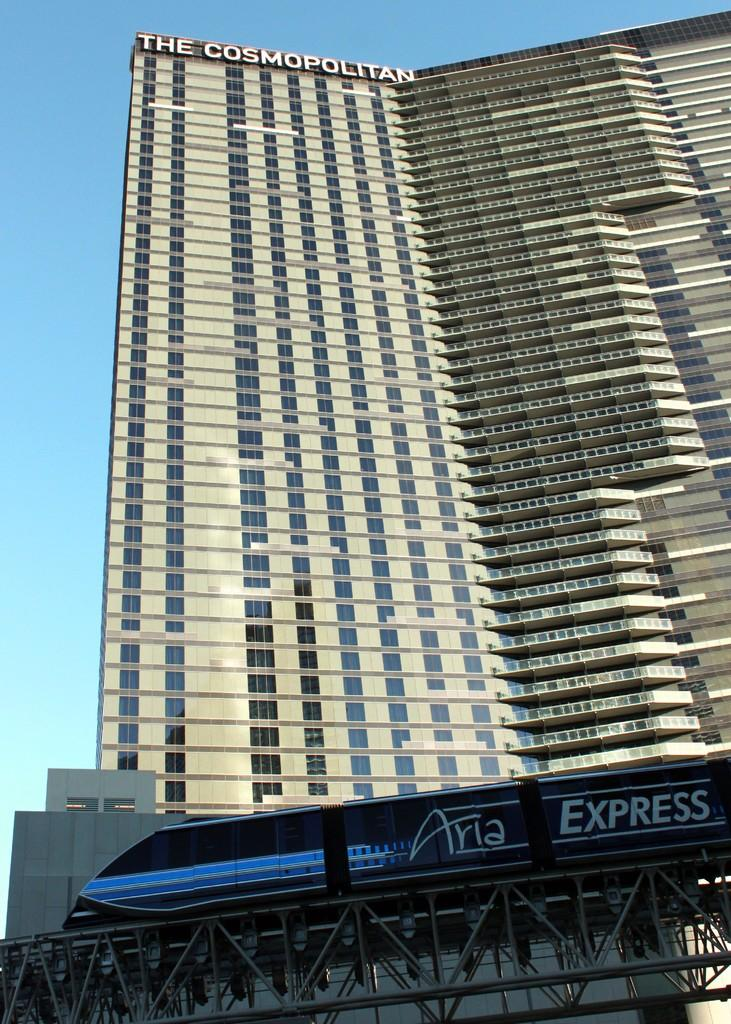<image>
Share a concise interpretation of the image provided. High Rise building at the very top says The Cospmopolitan. 